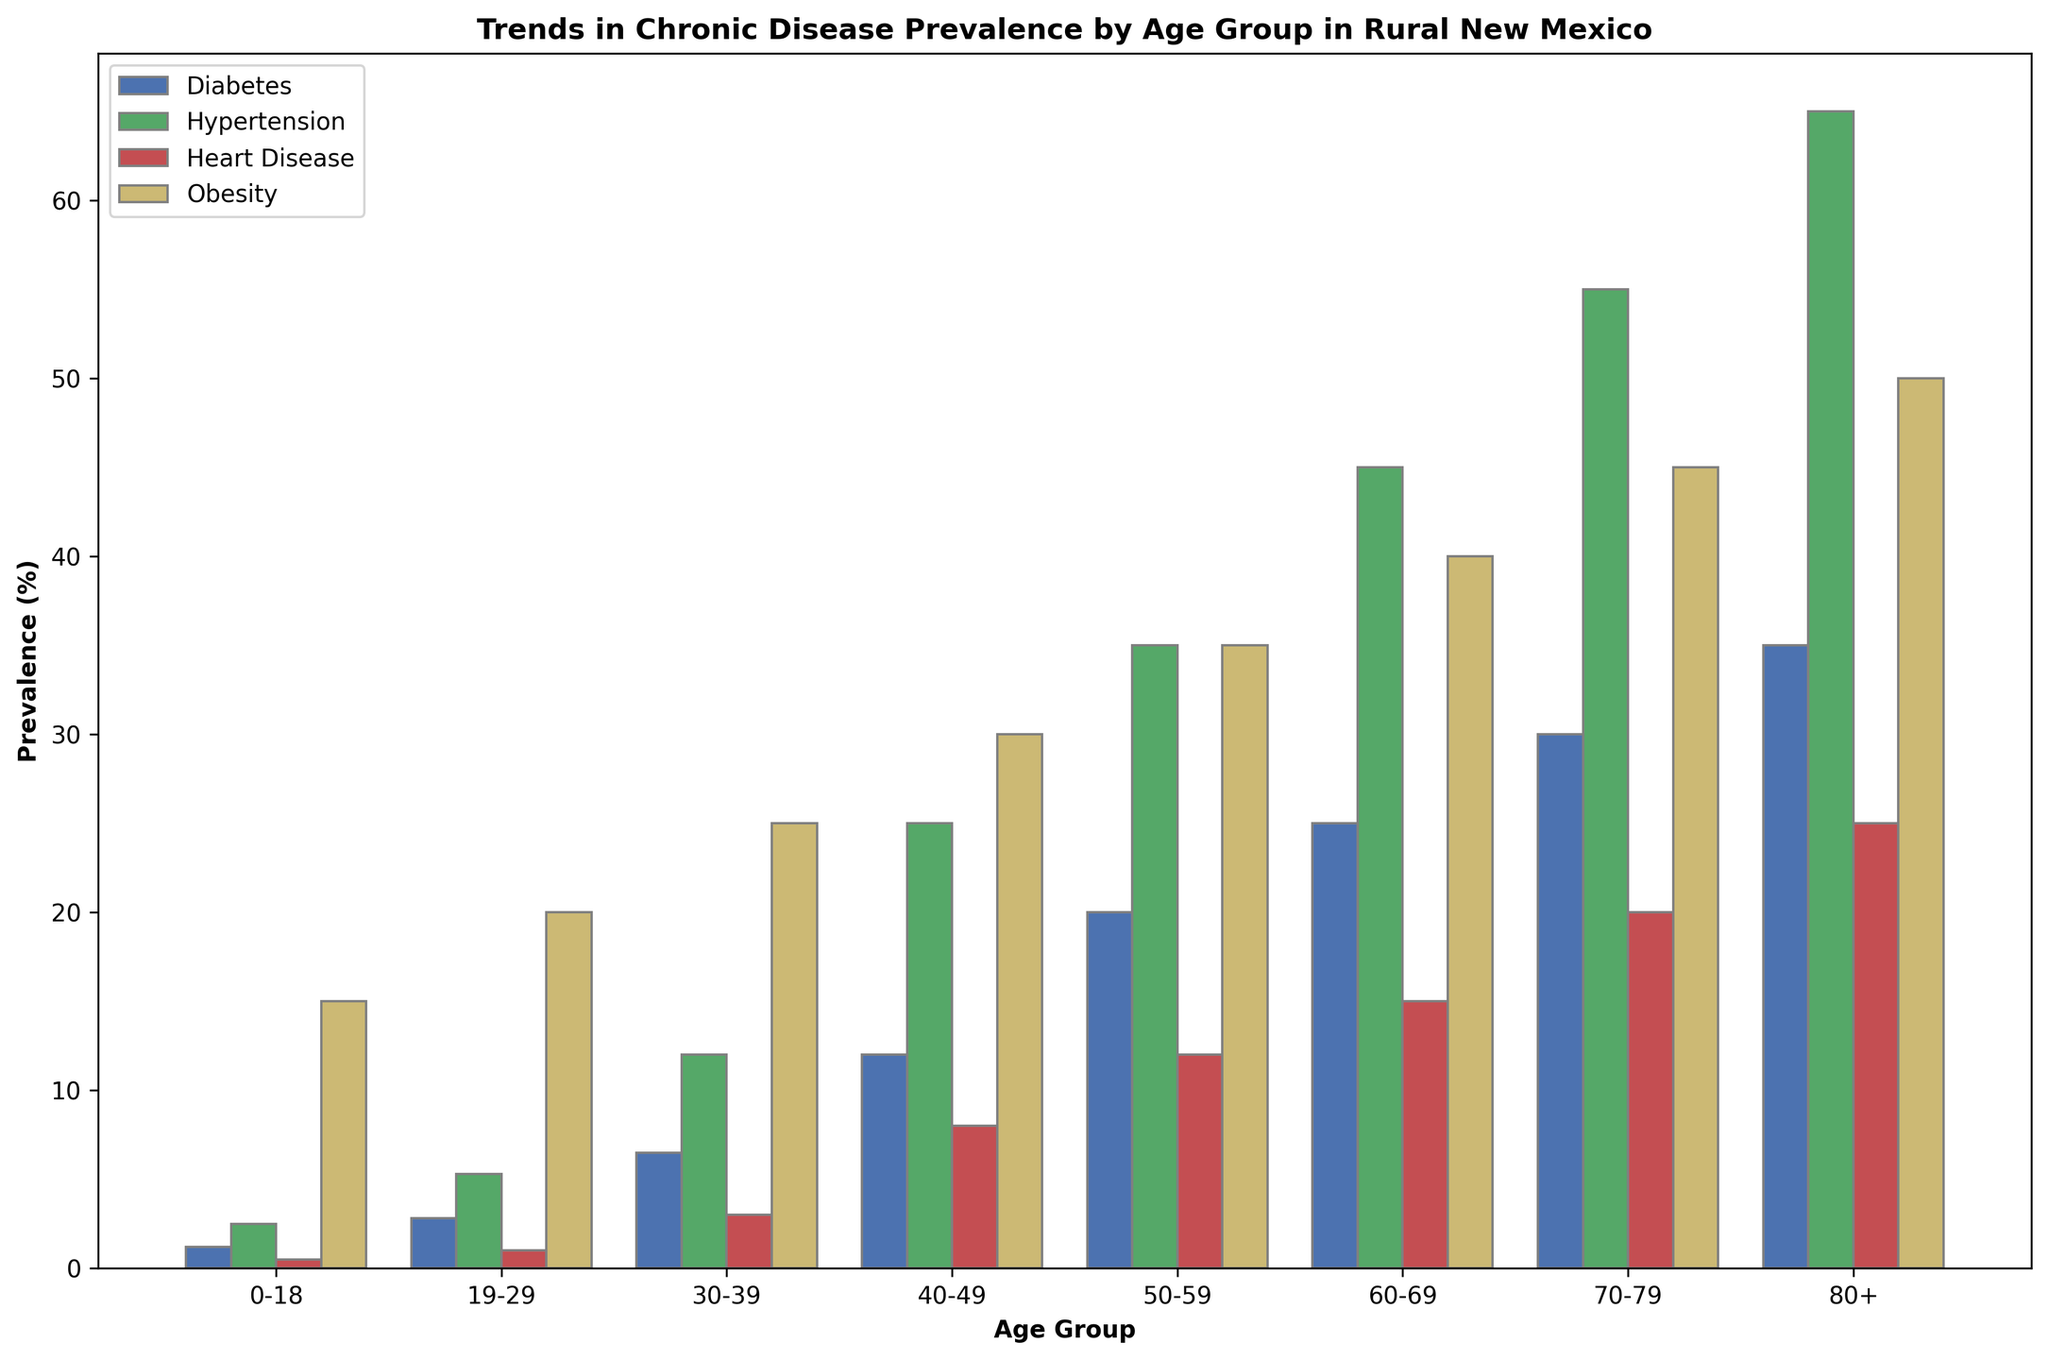What age group has the highest prevalence of diabetes? To determine this, look for the blue bar (representing diabetes) that is the tallest. The 80+ age group has the tallest blue bar.
Answer: 80+ Which chronic disease has the greatest increase in prevalence from the 0-18 age group to the 80+ age group? To find this, compare the difference in bar heights for each disease between the 0-18 and 80+ age groups. The diabetes prevalence increases from 1.2% to 35%, a difference of 33.8%, which is the largest increase.
Answer: Diabetes How does the prevalence of hypertension in the 60-69 age group compare to the prevalence of heart disease in the same age group? Look at the green bar (hypertension) and the red bar (heart disease) for the 60-69 age group. The green bar is at 45% and the red bar is at 15%, so hypertension is 30 percentage points higher.
Answer: Hypertension is higher by 30 percentage points What is the average prevalence of obesity across all age groups? Calculate the average by summing the obesity prevalence percentages for each age group and dividing by the number of age groups (8). (15+20+25+30+35+40+45+50) / 8 = 260 / 8 = 32.5%
Answer: 32.5% Which age group has the lowest prevalence of heart disease, and what is that prevalence? Look for the shortest red bar (representing heart disease). The shortest red bar is in the 0-18 age group.
Answer: 0-18, 0.5% Between which two consecutive age groups does the prevalence of diabetes increase the most? Examine the blue bars for each age group and calculate the difference between consecutive groups. The largest increase is between the 40-49 group (12%) and the 50-59 group (20%), which is an increase of 8 percentage points.
Answer: Between 40-49 and 50-59 Is the prevalence of hypertension higher or lower than the prevalence of obesity in the 30-39 age group? Compare the heights of the green bar (hypertension) and the yellow bar (obesity) for the 30-39 age group. The green bar is at 12%, and the yellow bar is at 25%, so obesity is higher.
Answer: Lower What is the total prevalence of all chronic diseases combined for the 19-29 age group? Sum the prevalences of diabetes, hypertension, heart disease, and obesity for the 19-29 age group: 2.8 + 5.3 + 1.0 + 20.0 = 29.1%
Answer: 29.1% What trend do you observe in the prevalence of obesity across different age groups? Look at the yellow bars from left to right, which represent obesity. They consistently increase in height as the age groups progress.
Answer: Consistently increasing What is the prevalence difference between hypertension and diabetes in the 70-79 age group? Subtract the prevalence of diabetes (the blue bar) from hypertension (the green bar) in the 70-79 age group: 55% - 30% = 25%.
Answer: 25% 